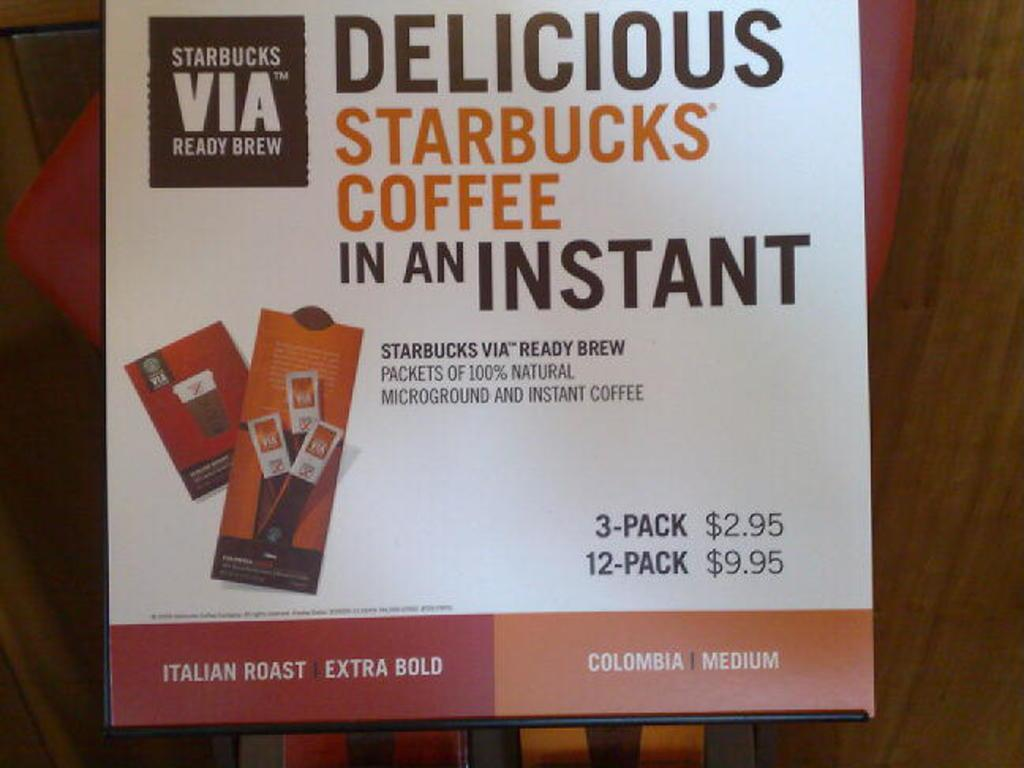<image>
Create a compact narrative representing the image presented. A poster advertising Delicious Starbucks Coffee in an Instant. 